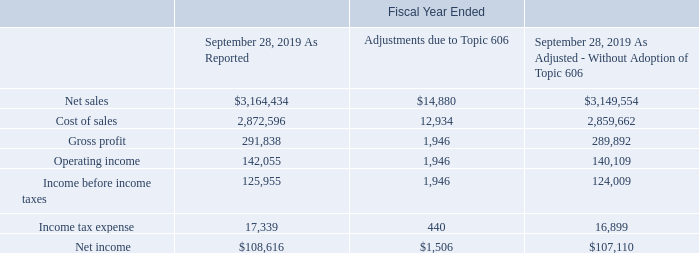15. Revenue from Contracts with Customers
Impact of Adopting Topic 606
The effects of the adoption on the Company's Consolidated Financial Statements for the fiscal year ended September 28, 2019 was as follows (in thousands):
What was the amount of Net Sales as reported?
Answer scale should be: thousand. 3,164,434. What was the cost of sales adjustments due to Topic 606?
Answer scale should be: thousand. 12,934. What was the Gross Profit after adjustment?
Answer scale should be: thousand. 289,892. How many types of revenues had adjustments that exceeded $10,000 thousand? Net sales##cost of sales
Answer: 2. What was the difference in the amount as reported between Operating income and income before income taxes?
Answer scale should be: thousand. 142,055-125,955
Answer: 16100. What was the percentage change in the net income before and after adjustments?
Answer scale should be: percent. (107,110-108,616)/108,616
Answer: -1.39. 